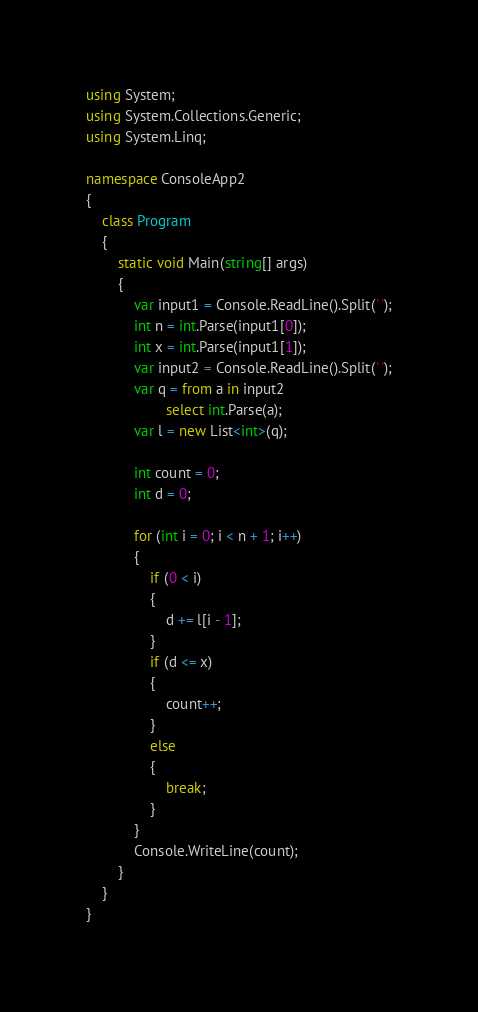<code> <loc_0><loc_0><loc_500><loc_500><_C#_>using System;
using System.Collections.Generic;
using System.Linq;

namespace ConsoleApp2
{
	class Program
	{
		static void Main(string[] args)
		{
			var input1 = Console.ReadLine().Split(' ');
			int n = int.Parse(input1[0]);
			int x = int.Parse(input1[1]);
			var input2 = Console.ReadLine().Split(' ');
			var q = from a in input2
					select int.Parse(a);
			var l = new List<int>(q);

			int count = 0;
			int d = 0;

			for (int i = 0; i < n + 1; i++)
			{
				if (0 < i)
				{
					d += l[i - 1];
				}
				if (d <= x)
				{
					count++;
				}
				else
				{
					break;
				}
			}
			Console.WriteLine(count);
		}
	}
}
</code> 